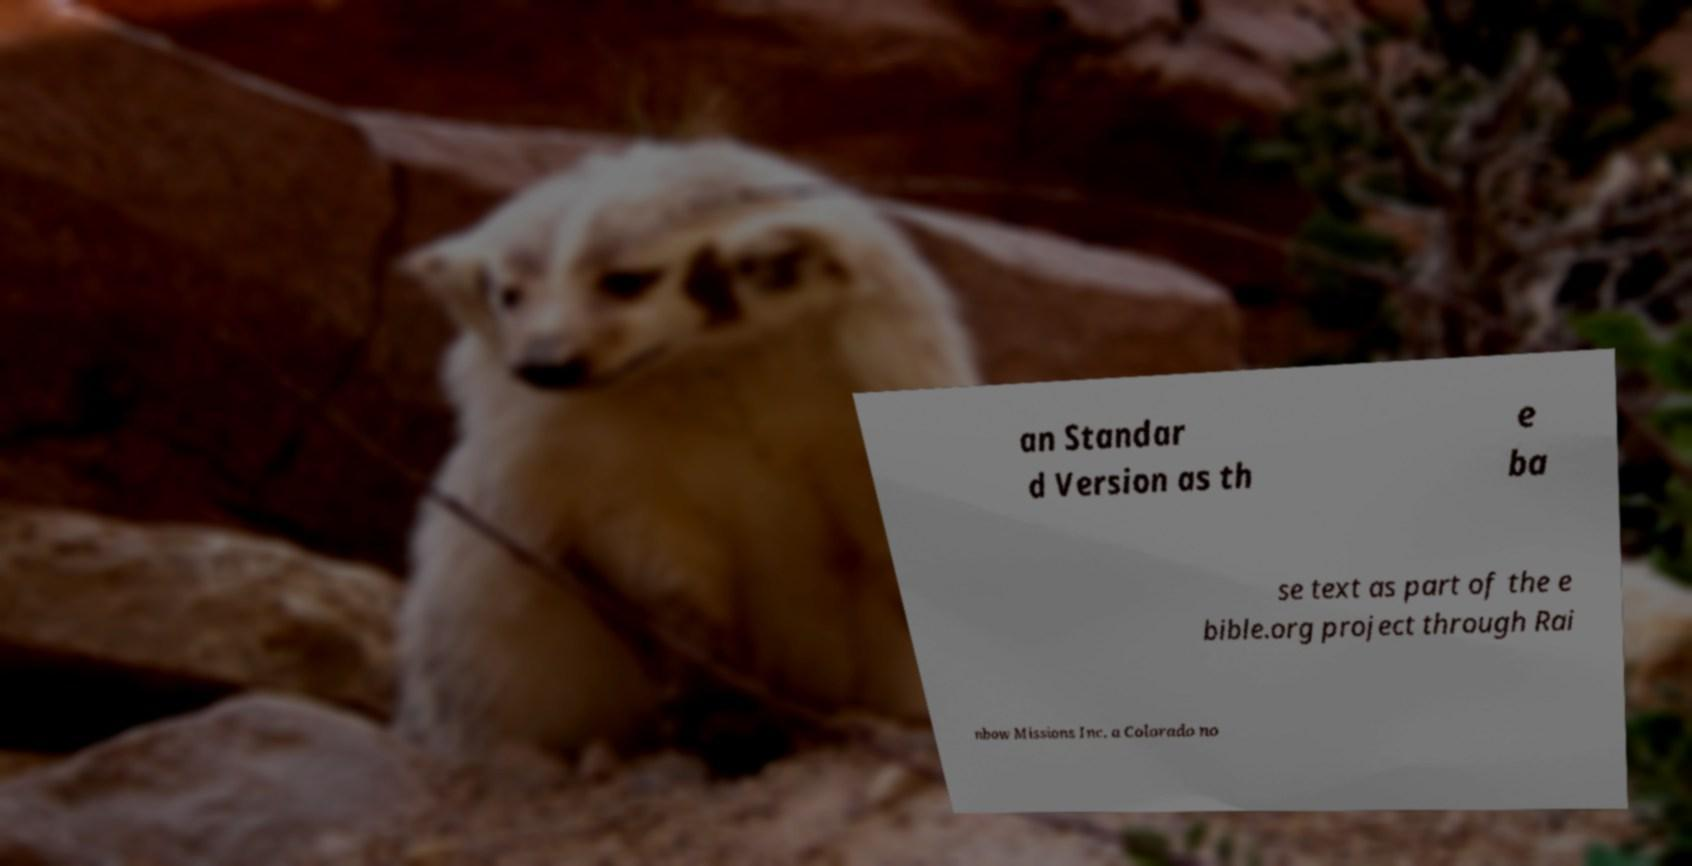I need the written content from this picture converted into text. Can you do that? an Standar d Version as th e ba se text as part of the e bible.org project through Rai nbow Missions Inc. a Colorado no 